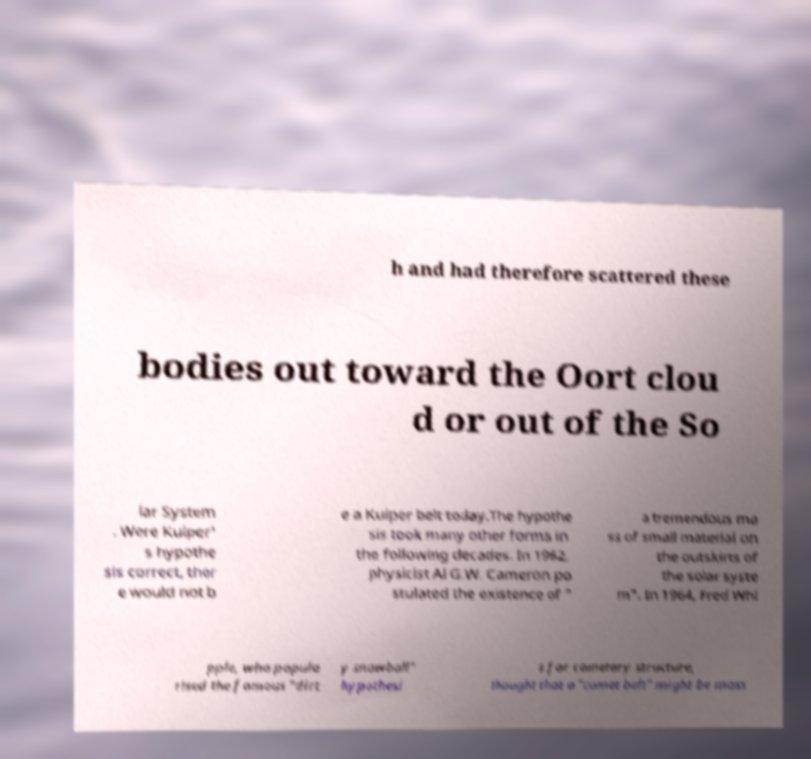For documentation purposes, I need the text within this image transcribed. Could you provide that? h and had therefore scattered these bodies out toward the Oort clou d or out of the So lar System . Were Kuiper' s hypothe sis correct, ther e would not b e a Kuiper belt today.The hypothe sis took many other forms in the following decades. In 1962, physicist Al G.W. Cameron po stulated the existence of " a tremendous ma ss of small material on the outskirts of the solar syste m". In 1964, Fred Whi pple, who popula rised the famous "dirt y snowball" hypothesi s for cometary structure, thought that a "comet belt" might be mass 